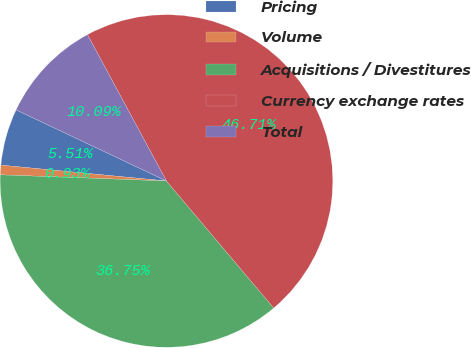Convert chart. <chart><loc_0><loc_0><loc_500><loc_500><pie_chart><fcel>Pricing<fcel>Volume<fcel>Acquisitions / Divestitures<fcel>Currency exchange rates<fcel>Total<nl><fcel>5.51%<fcel>0.93%<fcel>36.75%<fcel>46.71%<fcel>10.09%<nl></chart> 